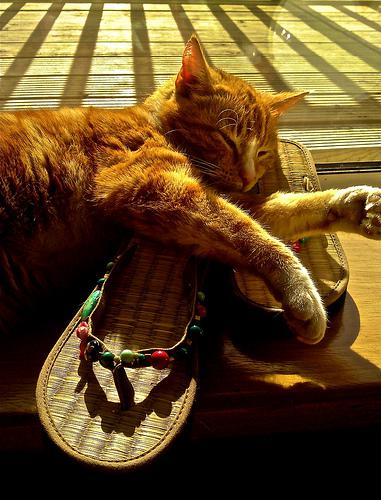Question: how is the cat?
Choices:
A. Sad.
B. Motionless.
C. Slow.
D. Sleepy.
Answer with the letter. Answer: B Question: what is in the photo?
Choices:
A. A house.
B. A deer.
C. A cat.
D. A volcano.
Answer with the letter. Answer: C 